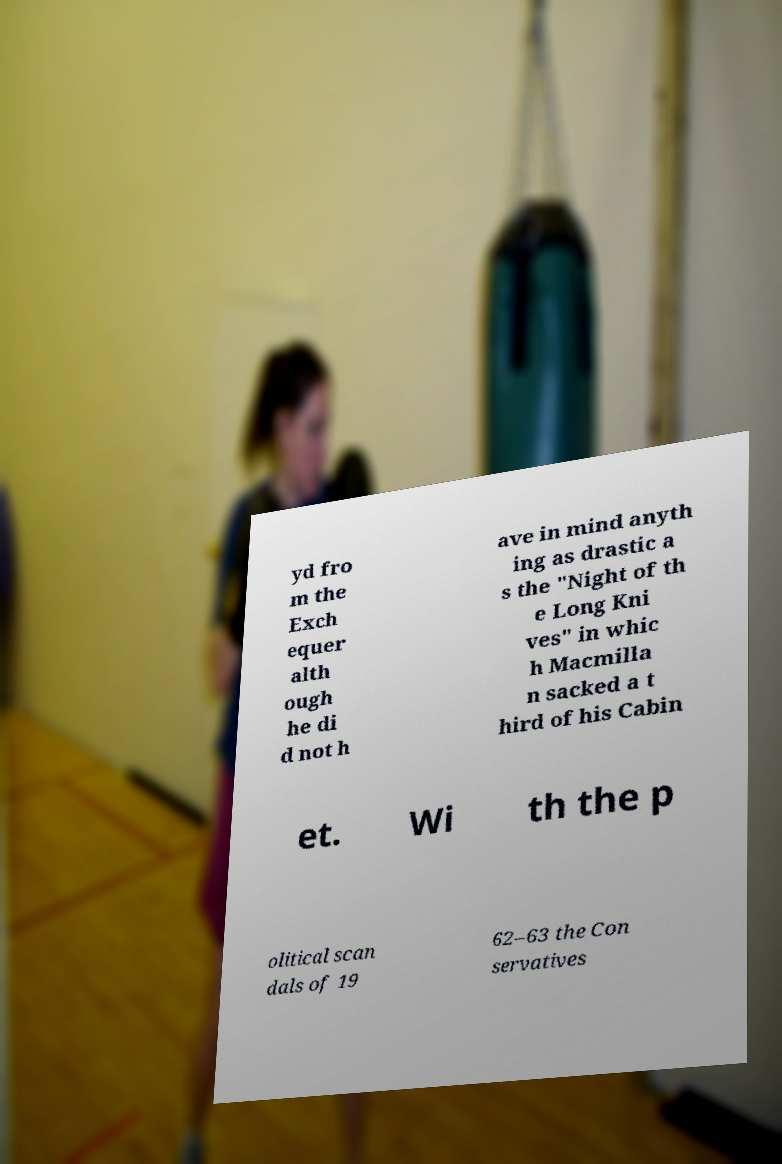Can you accurately transcribe the text from the provided image for me? yd fro m the Exch equer alth ough he di d not h ave in mind anyth ing as drastic a s the "Night of th e Long Kni ves" in whic h Macmilla n sacked a t hird of his Cabin et. Wi th the p olitical scan dals of 19 62–63 the Con servatives 